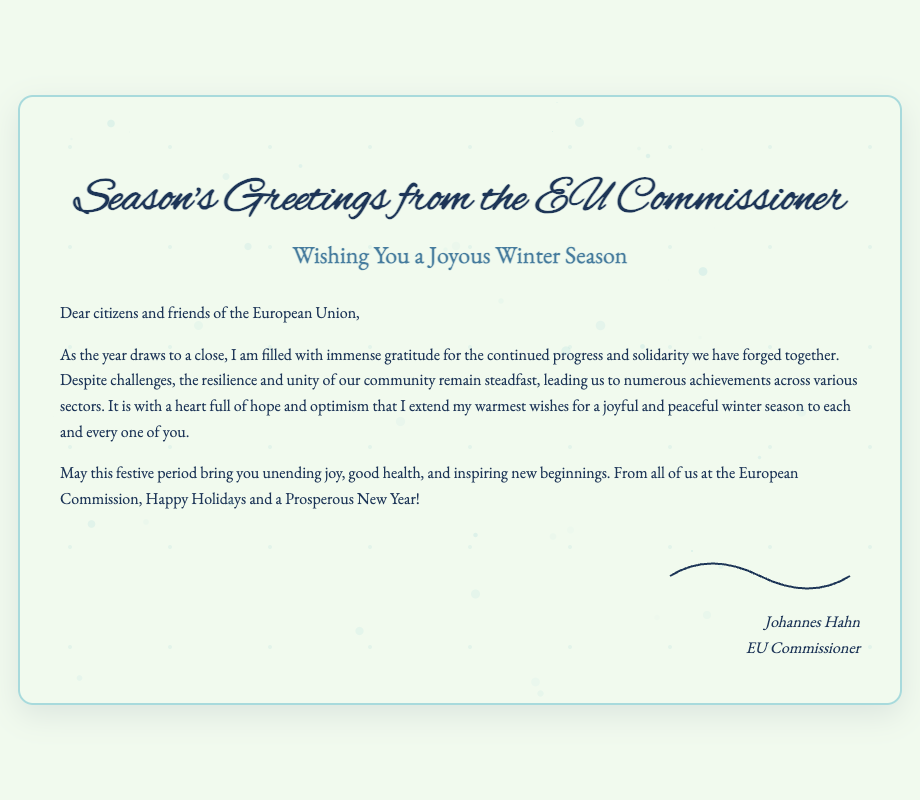What is the title of the card? The title of the card is prominently displayed at the top of the document, introducing the theme.
Answer: Season's Greetings from the EU Commissioner Who is the author of the greetings? The signature at the bottom of the card identifies the person who authored the message.
Answer: Johannes Hahn What is the color theme of the card? The document conveys an elegant winter theme with specific color tones emphasized throughout the design.
Answer: Winter How many snowflakes are created in the document? The script generates a specified number of snowflakes for a festive visual effect.
Answer: 50 What does the EU Commissioner wish for citizens? The message reflects the author's heartfelt wishes directed towards the EU citizens, capturing the essence of the festive spirit.
Answer: Joyful and peaceful winter season What is the font used for the title? The title's font is uniquely chosen to evoke elegance and celebration, differentiating it from the rest of the text.
Answer: Alex Brush What is the primary message conveyed in the content? The essence of the message focuses on unity and well-wishing for the coming year, emphasizing the accomplishments throughout the past year.
Answer: Gratitude for progress and solidarity What does the Commissioner extend to the recipients? The concluding element of the greeting card highlights the sender's cheer and hopes for the recipients.
Answer: Happy Holidays and a Prosperous New Year! 